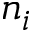Convert formula to latex. <formula><loc_0><loc_0><loc_500><loc_500>n _ { i }</formula> 